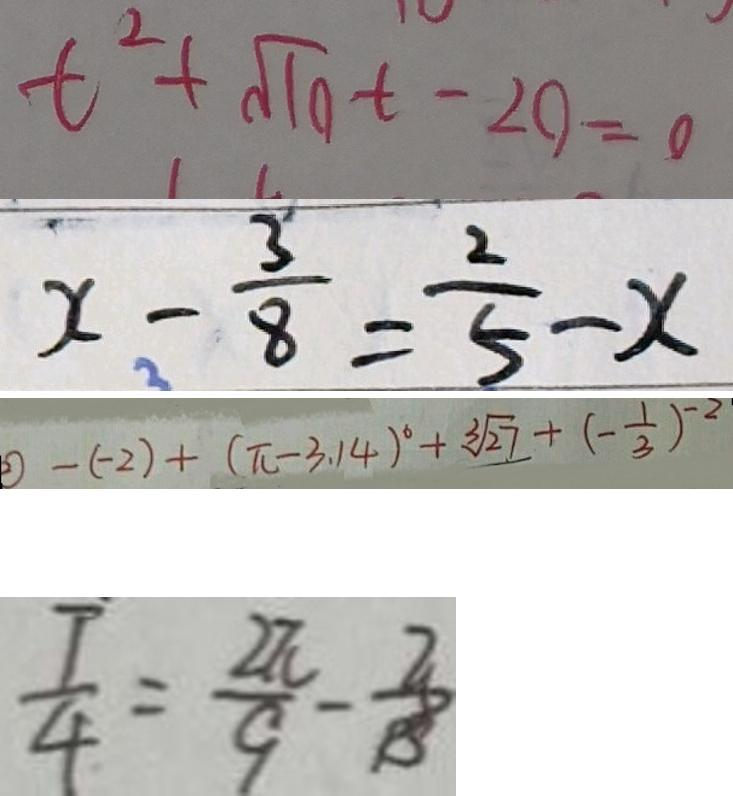<formula> <loc_0><loc_0><loc_500><loc_500>t ^ { 2 } + \sqrt { 1 0 } t - 2 0 = 0 
 x - \frac { 3 } { 8 } = \frac { 2 } { 5 } - x 
 \textcircled { 2 } - ( - 2 ) + ( \pi - 3 . 1 4 ) ^ { 6 } + \sqrt [ 3 ] { 2 7 } + ( - \frac { 1 } { 3 } ) ^ { - 2 } 
 \frac { T } { 4 } = \frac { 2 \pi } { 9 } - \frac { 3 } { 1 3 }</formula> 